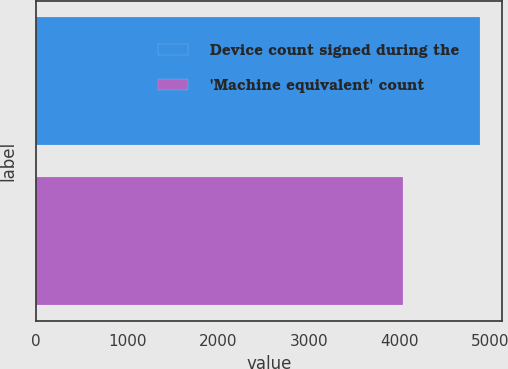Convert chart to OTSL. <chart><loc_0><loc_0><loc_500><loc_500><bar_chart><fcel>Device count signed during the<fcel>'Machine equivalent' count<nl><fcel>4881<fcel>4032<nl></chart> 